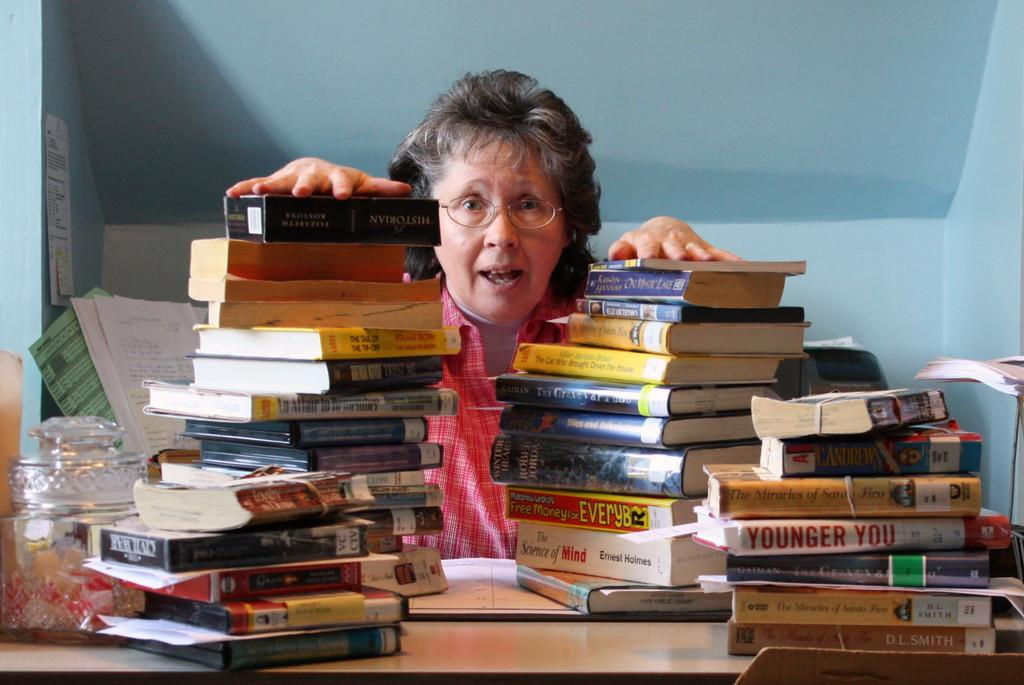What can be seen in the image in terms of books? There are rows of books in the image. Can you describe the person's interaction with the books? A person is touching the books from behind. What is visible in the background of the image? There are walls in the background of the image. What other object can be seen in the background? There is a pet jar with candies in the background of the image. What type of seed is being planted in the image? There is no seed or planting activity present in the image. How does the person react to the candies in the pet jar? The image does not show the person's reaction to the candies in the pet jar. 